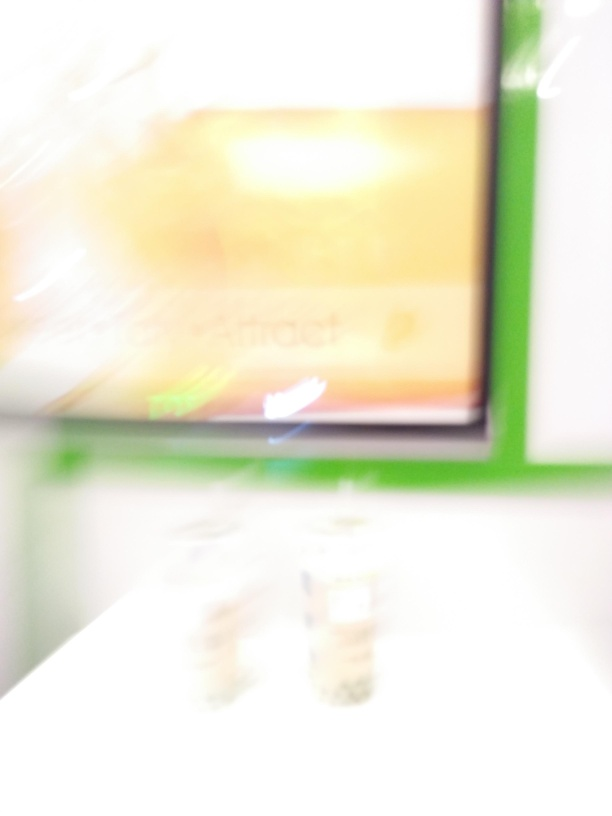Can you tell what kind of place this is despite the blur? It's difficult to make out specific details due to the blurriness, but the presence of a brightly lit area with what seems to be a rectangular display or sign might suggest this is an indoor setting, such as a shop or public facility. Is there anything in the image that gives a clue about the location? The image quality is too low to identify clear markers that would indicate the location. One would need a higher-resolution image to derive any meaningful clues about the setting. 